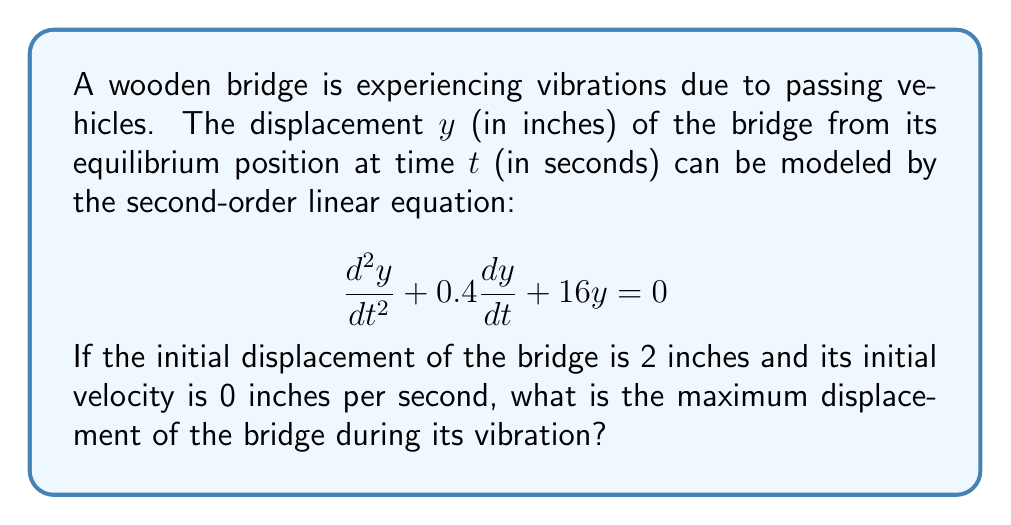Provide a solution to this math problem. To solve this problem, we need to follow these steps:

1) First, we recognize this as a damped harmonic oscillator equation. The general form is:

   $$\frac{d^2y}{dt^2} + 2\beta\frac{dy}{dt} + \omega_0^2y = 0$$

   where $\beta$ is the damping coefficient and $\omega_0$ is the natural frequency.

2) In our case, $2\beta = 0.4$ and $\omega_0^2 = 16$. So, $\beta = 0.2$ and $\omega_0 = 4$.

3) To determine the type of damping, we calculate $\beta^2 - \omega_0^2$:

   $0.2^2 - 4^2 = 0.04 - 16 = -15.96 < 0$

   This indicates underdamped motion.

4) For underdamped motion, the solution has the form:

   $y(t) = Ae^{-\beta t}\cos(\omega t - \phi)$

   where $\omega = \sqrt{\omega_0^2 - \beta^2} = \sqrt{16 - 0.04} = 3.9987$

5) The amplitude $A$ and phase $\phi$ are determined by initial conditions. However, we don't need to solve for these to find the maximum displacement.

6) In underdamped motion, the maximum displacement occurs at $t=0$ and is equal to the initial displacement.

7) We're given that the initial displacement is 2 inches.

Therefore, the maximum displacement of the bridge during its vibration is 2 inches.
Answer: 2 inches 